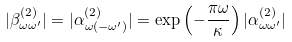<formula> <loc_0><loc_0><loc_500><loc_500>| \beta _ { \omega \omega ^ { \prime } } ^ { ( 2 ) } | = | \alpha _ { \omega ( - \omega ^ { \prime } ) } ^ { ( 2 ) } | = \exp \left ( - \frac { \pi \omega } { \kappa } \right ) | \alpha _ { \omega \omega ^ { \prime } } ^ { ( 2 ) } |</formula> 